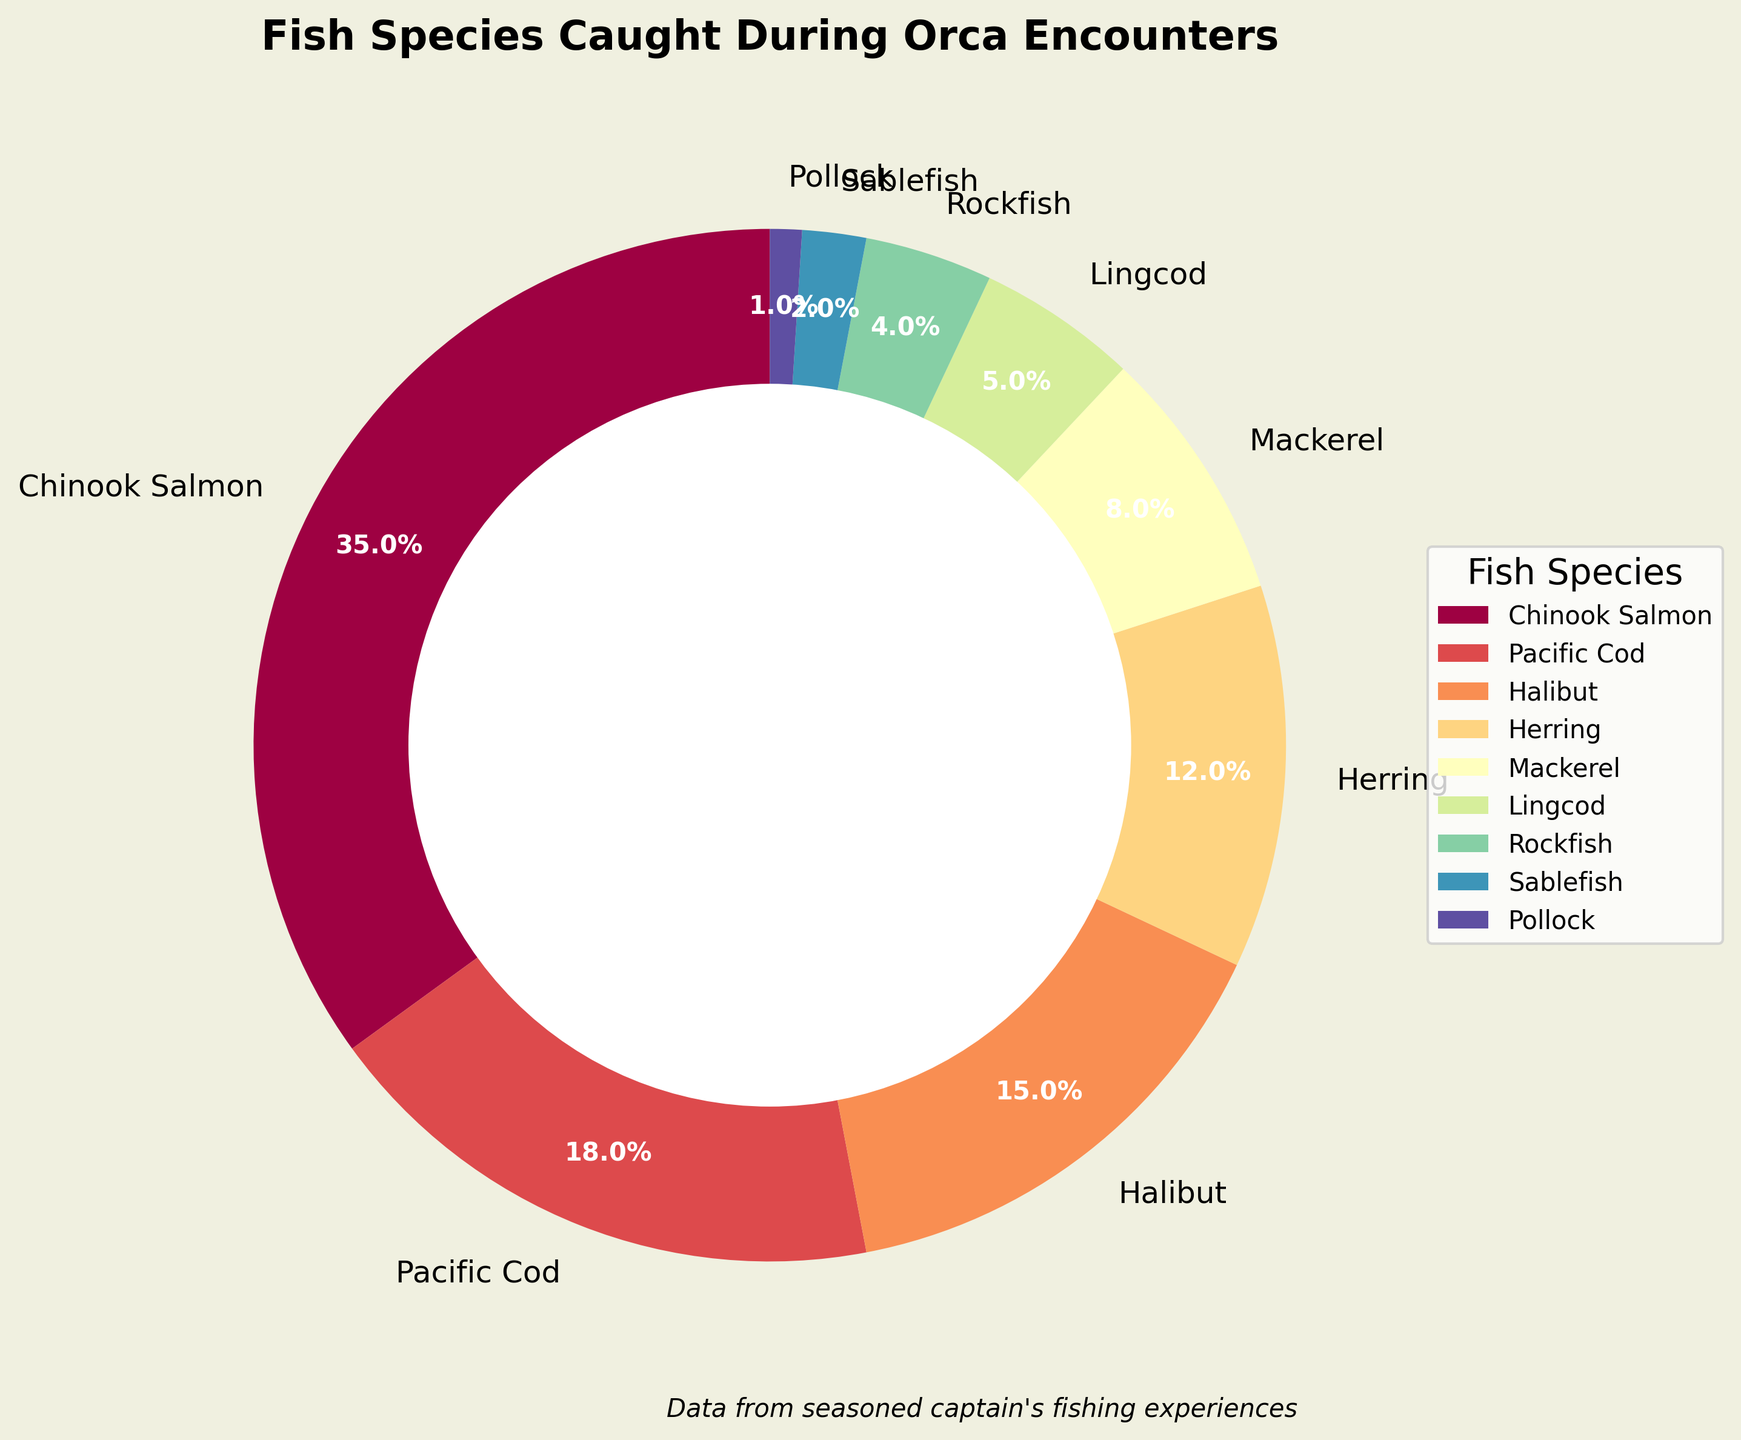Which species of fish has the highest percentage in the pie chart? The largest portion of the pie chart is taken up by Chinook Salmon, which is labeled with 35%.
Answer: Chinook Salmon Which fish species is caught more frequently, Halibut or Mackerel? Halibut occupies a larger portion of the pie chart at 15%, while Mackerel has a smaller portion at 8%.
Answer: Halibut What is the combined percentage of Pacific Cod and Herring? The percentages for Pacific Cod (18%) and Herring (12%) add up to 30%.
Answer: 30% How much larger is the share of Chinook Salmon compared to Lingcod? Chinook Salmon is 35%, and Lingcod is 5%. The difference is 35% - 5% = 30%.
Answer: 30% How does the proportion of Rockfish compare to Sablefish in the chart? Rockfish has a larger proportion than Sablefish. Rockfish is 4%, while Sablefish is 2%.
Answer: Rockfish Which fish species has the smallest percentage in the pie chart? Pollock has the smallest portion with 1%.
Answer: Pollock What is the total percentage of the species that each account for less than 10% of the catch? The species with less than 10% are Mackerel (8%), Lingcod (5%), Rockfish (4%), Sablefish (2%), and Pollock (1%). Adding them up: 8% + 5% + 4% + 2% + 1% = 20%.
Answer: 20% What color represents the Sablefish portion of the pie chart? According to the color scheme from the Spectral colormap, the Sablefish portion would typically appear towards the cooler end, likely a shade of blue.
Answer: Blue (likely) If you were to combine the percentages for all species labeled with "fish" in their names, what would be the total percentage? Combining Halibut (15%), Lingcod (5%), Rockfish (4%), Sablefish (2%), and Pollock (1%): 15% + 5% + 4% + 2% + 1% = 27%.
Answer: 27% 